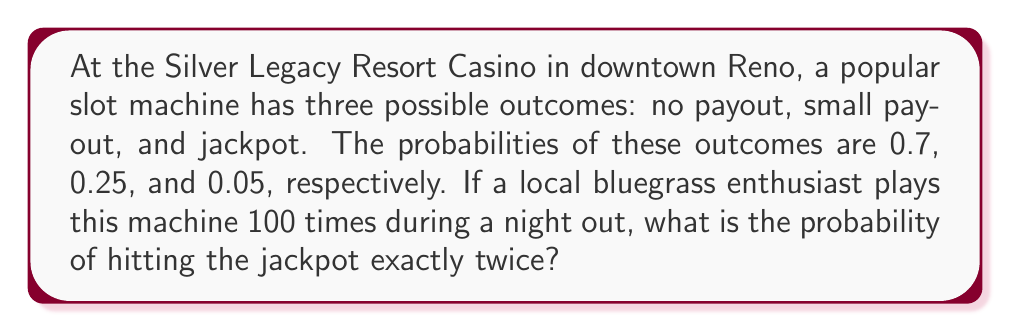Help me with this question. Let's approach this step-by-step using the binomial probability distribution:

1) This scenario follows a binomial distribution because:
   - There are a fixed number of independent trials (100 plays)
   - Each trial has two possible outcomes (jackpot or no jackpot)
   - The probability of success (hitting the jackpot) remains constant

2) We'll use the binomial probability formula:

   $$P(X = k) = \binom{n}{k} p^k (1-p)^{n-k}$$

   Where:
   $n$ = number of trials (100)
   $k$ = number of successes (2)
   $p$ = probability of success on each trial (0.05)

3) Let's calculate each part:

   $\binom{n}{k} = \binom{100}{2} = \frac{100!}{2!(100-2)!} = 4950$

   $p^k = 0.05^2 = 0.0025$

   $(1-p)^{n-k} = 0.95^{98} \approx 0.0066$

4) Now, let's put it all together:

   $$P(X = 2) = 4950 \times 0.0025 \times 0.0066 \approx 0.0815$$

5) Convert to a percentage:

   $0.0815 \times 100\% = 8.15\%$
Answer: 8.15% 